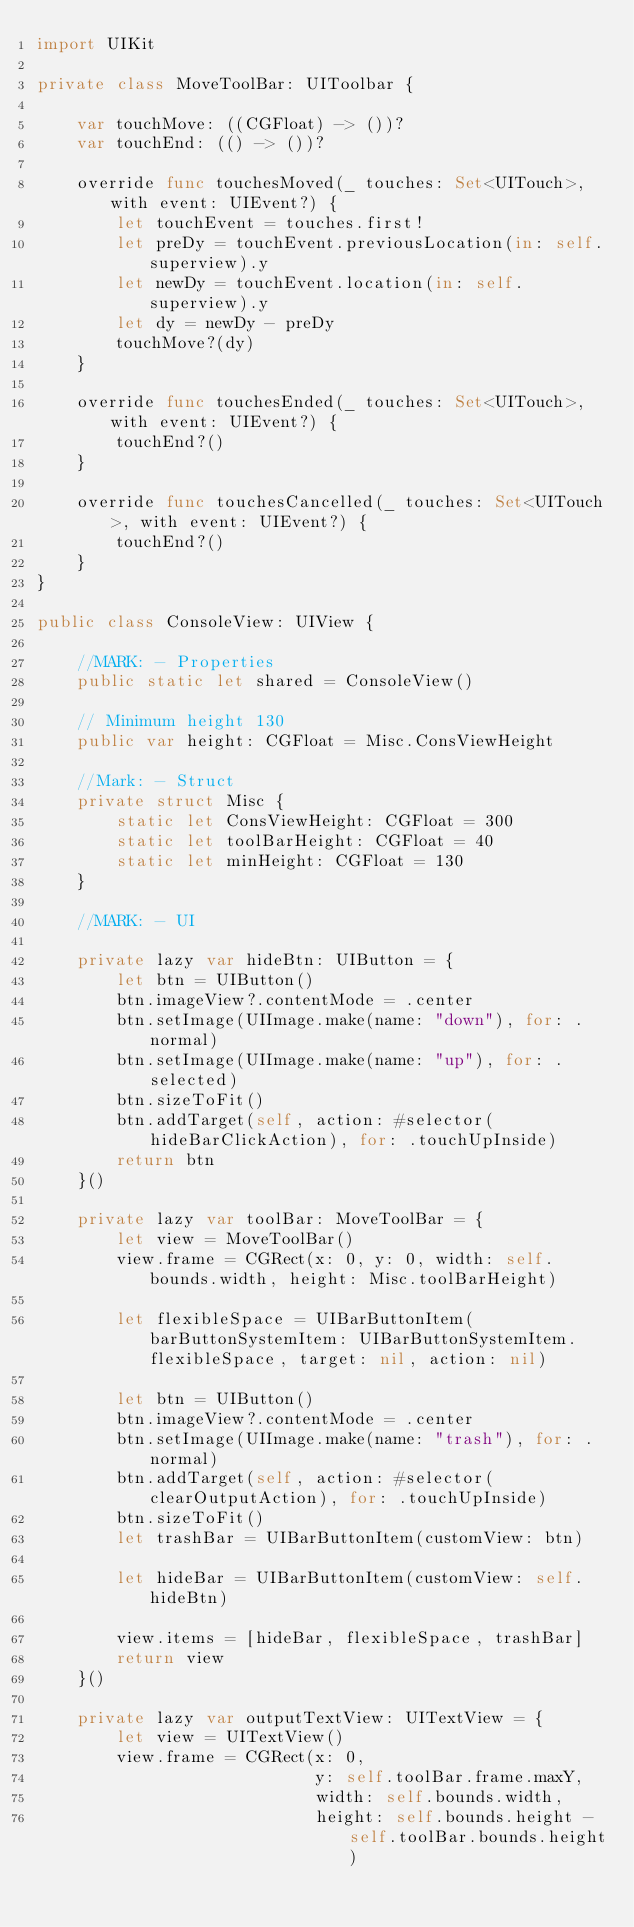Convert code to text. <code><loc_0><loc_0><loc_500><loc_500><_Swift_>import UIKit

private class MoveToolBar: UIToolbar {
    
    var touchMove: ((CGFloat) -> ())?
    var touchEnd: (() -> ())?
    
    override func touchesMoved(_ touches: Set<UITouch>, with event: UIEvent?) {
        let touchEvent = touches.first!
        let preDy = touchEvent.previousLocation(in: self.superview).y
        let newDy = touchEvent.location(in: self.superview).y
        let dy = newDy - preDy
        touchMove?(dy)
    }
    
    override func touchesEnded(_ touches: Set<UITouch>, with event: UIEvent?) {
        touchEnd?()
    }
    
    override func touchesCancelled(_ touches: Set<UITouch>, with event: UIEvent?) {
        touchEnd?()
    }
}

public class ConsoleView: UIView {
    
    //MARK: - Properties
    public static let shared = ConsoleView()
    
    // Minimum height 130
    public var height: CGFloat = Misc.ConsViewHeight
    
    //Mark: - Struct
    private struct Misc {
        static let ConsViewHeight: CGFloat = 300
        static let toolBarHeight: CGFloat = 40
        static let minHeight: CGFloat = 130
    }
    
    //MARK: - UI
    
    private lazy var hideBtn: UIButton = {
        let btn = UIButton()
        btn.imageView?.contentMode = .center
        btn.setImage(UIImage.make(name: "down"), for: .normal)
        btn.setImage(UIImage.make(name: "up"), for: .selected)
        btn.sizeToFit()
        btn.addTarget(self, action: #selector(hideBarClickAction), for: .touchUpInside)
        return btn
    }()
    
    private lazy var toolBar: MoveToolBar = {
        let view = MoveToolBar()
        view.frame = CGRect(x: 0, y: 0, width: self.bounds.width, height: Misc.toolBarHeight)
        
        let flexibleSpace = UIBarButtonItem(barButtonSystemItem: UIBarButtonSystemItem.flexibleSpace, target: nil, action: nil)
        
        let btn = UIButton()
        btn.imageView?.contentMode = .center
        btn.setImage(UIImage.make(name: "trash"), for: .normal)
        btn.addTarget(self, action: #selector(clearOutputAction), for: .touchUpInside)
        btn.sizeToFit()
        let trashBar = UIBarButtonItem(customView: btn)
        
        let hideBar = UIBarButtonItem(customView: self.hideBtn)
        
        view.items = [hideBar, flexibleSpace, trashBar]
        return view
    }()
    
    private lazy var outputTextView: UITextView = {
        let view = UITextView()
        view.frame = CGRect(x: 0,
                            y: self.toolBar.frame.maxY,
                            width: self.bounds.width,
                            height: self.bounds.height - self.toolBar.bounds.height)</code> 